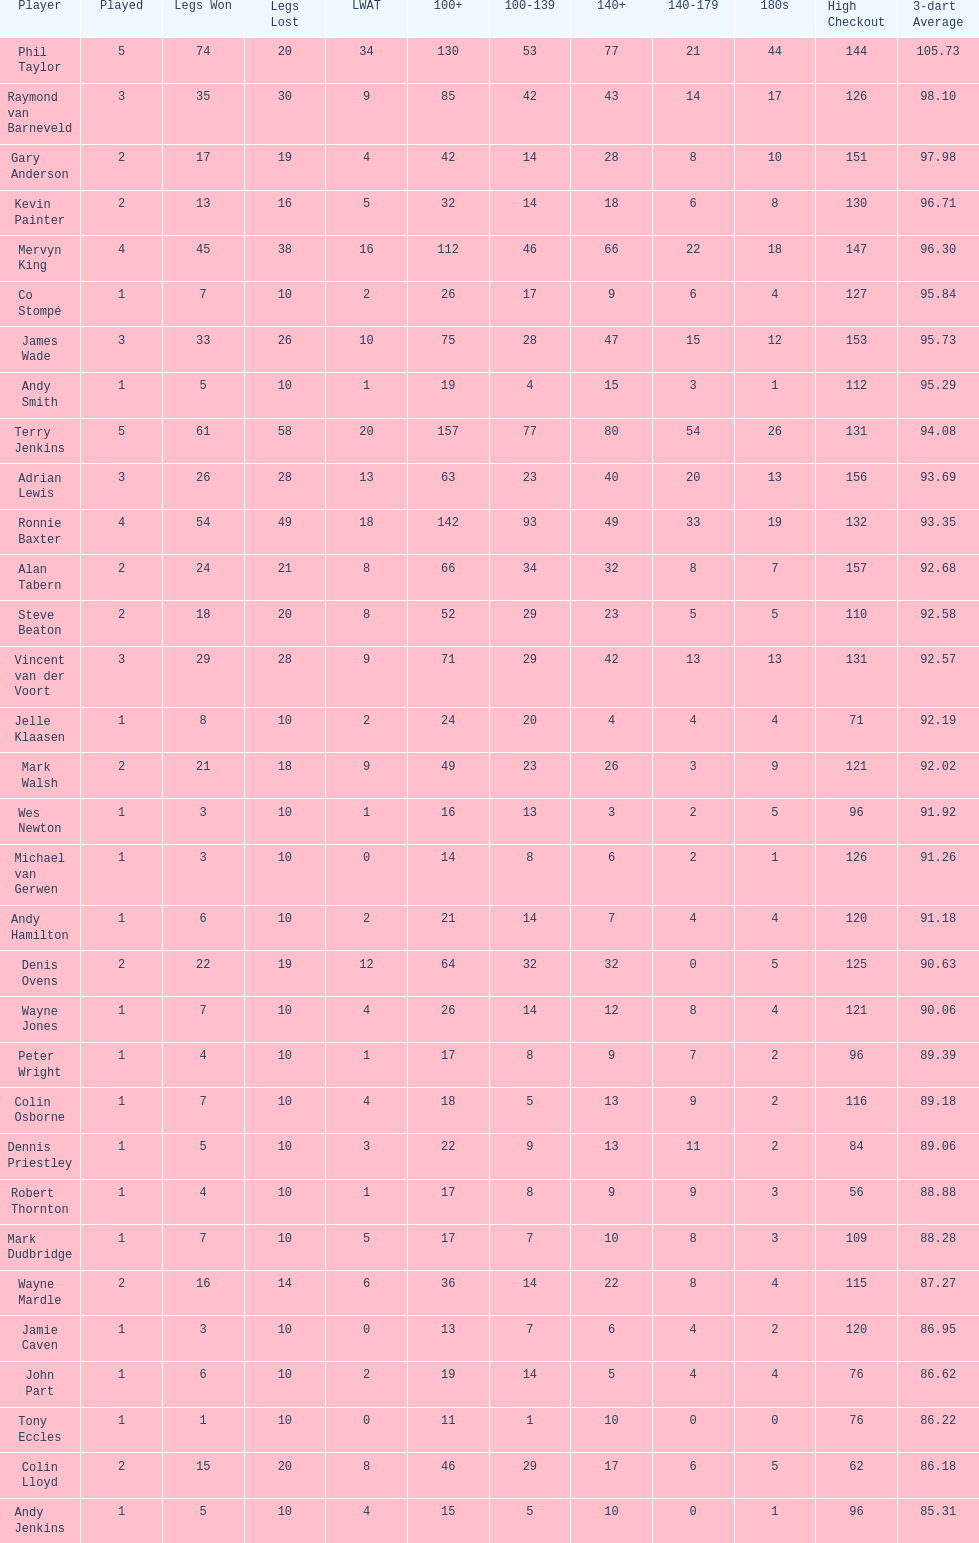Which player lost the least? Co Stompé, Andy Smith, Jelle Klaasen, Wes Newton, Michael van Gerwen, Andy Hamilton, Wayne Jones, Peter Wright, Colin Osborne, Dennis Priestley, Robert Thornton, Mark Dudbridge, Jamie Caven, John Part, Tony Eccles, Andy Jenkins. 